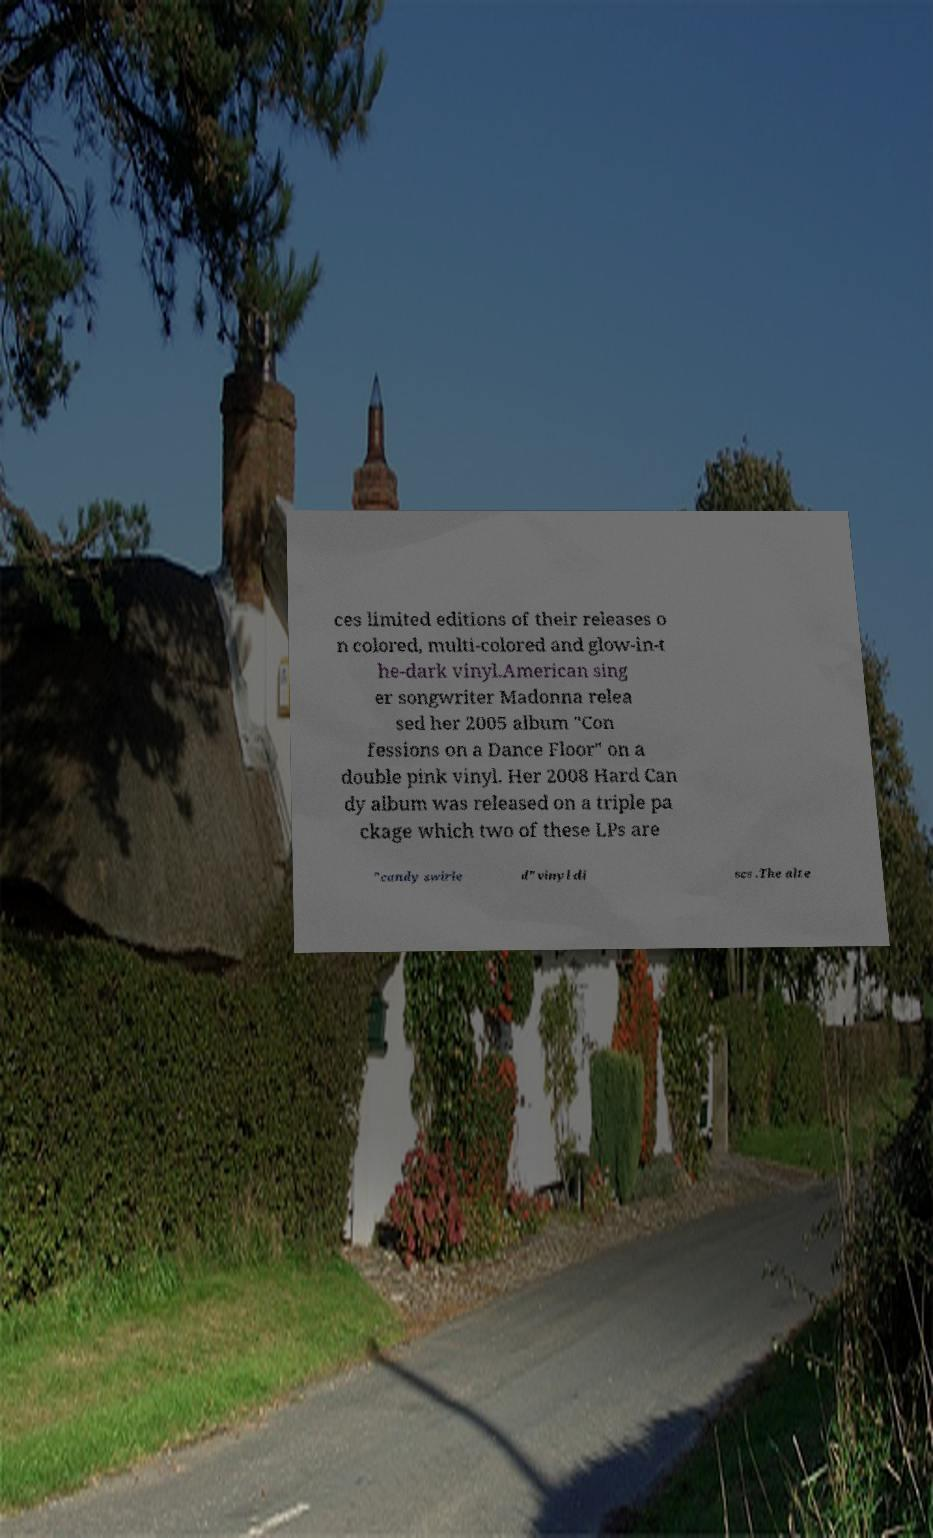Could you assist in decoding the text presented in this image and type it out clearly? ces limited editions of their releases o n colored, multi-colored and glow-in-t he-dark vinyl.American sing er songwriter Madonna relea sed her 2005 album "Con fessions on a Dance Floor" on a double pink vinyl. Her 2008 Hard Can dy album was released on a triple pa ckage which two of these LPs are "candy swirle d" vinyl di scs .The alte 